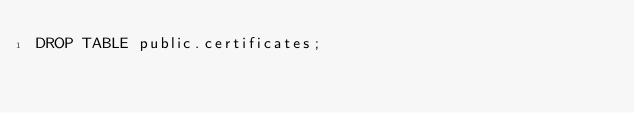<code> <loc_0><loc_0><loc_500><loc_500><_SQL_>DROP TABLE public.certificates;</code> 